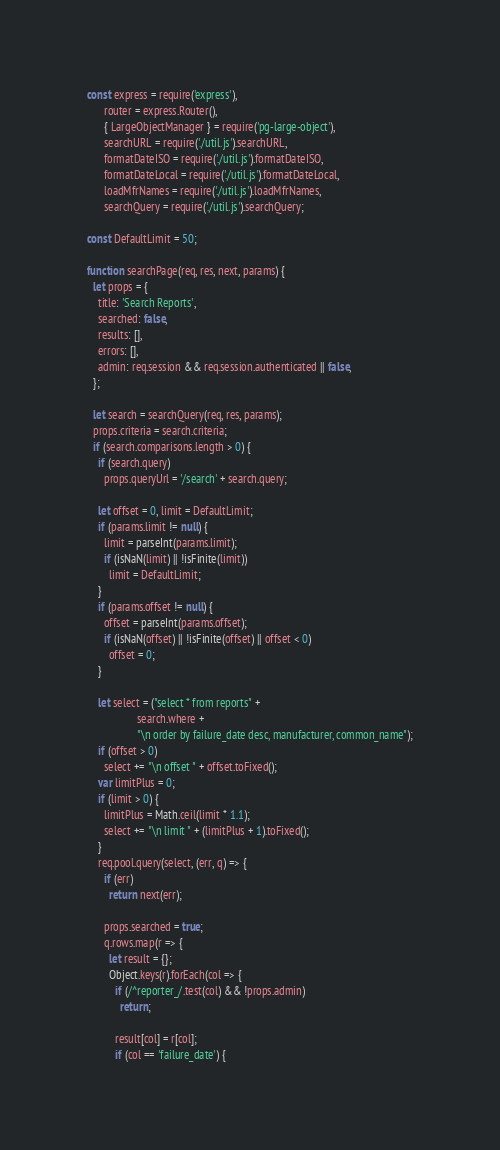Convert code to text. <code><loc_0><loc_0><loc_500><loc_500><_JavaScript_>const express = require('express'),
      router = express.Router(),
      { LargeObjectManager } = require('pg-large-object'),
      searchURL = require('./util.js').searchURL,
      formatDateISO = require('./util.js').formatDateISO,
      formatDateLocal = require('./util.js').formatDateLocal,
      loadMfrNames = require('./util.js').loadMfrNames,
      searchQuery = require('./util.js').searchQuery;

const DefaultLimit = 50;

function searchPage(req, res, next, params) {
  let props = {
    title: 'Search Reports',
    searched: false,
    results: [],
    errors: [],
    admin: req.session && req.session.authenticated || false,
  };

  let search = searchQuery(req, res, params);
  props.criteria = search.criteria;
  if (search.comparisons.length > 0) {
    if (search.query)
      props.queryUrl = '/search' + search.query;

    let offset = 0, limit = DefaultLimit;
    if (params.limit != null) {
      limit = parseInt(params.limit);
      if (isNaN(limit) || !isFinite(limit))
        limit = DefaultLimit;
    }
    if (params.offset != null) {
      offset = parseInt(params.offset);
      if (isNaN(offset) || !isFinite(offset) || offset < 0)
        offset = 0;
    }

    let select = ("select * from reports" +
                  search.where +
                  "\n order by failure_date desc, manufacturer, common_name");
    if (offset > 0)
      select += "\n offset " + offset.toFixed();
    var limitPlus = 0;
    if (limit > 0) {
      limitPlus = Math.ceil(limit * 1.1);
      select += "\n limit " + (limitPlus + 1).toFixed();
    }
    req.pool.query(select, (err, q) => {
      if (err)
        return next(err);

      props.searched = true;
      q.rows.map(r => {
        let result = {};
        Object.keys(r).forEach(col => {
          if (/^reporter_/.test(col) && !props.admin)
            return;

          result[col] = r[col];
          if (col == 'failure_date') {</code> 